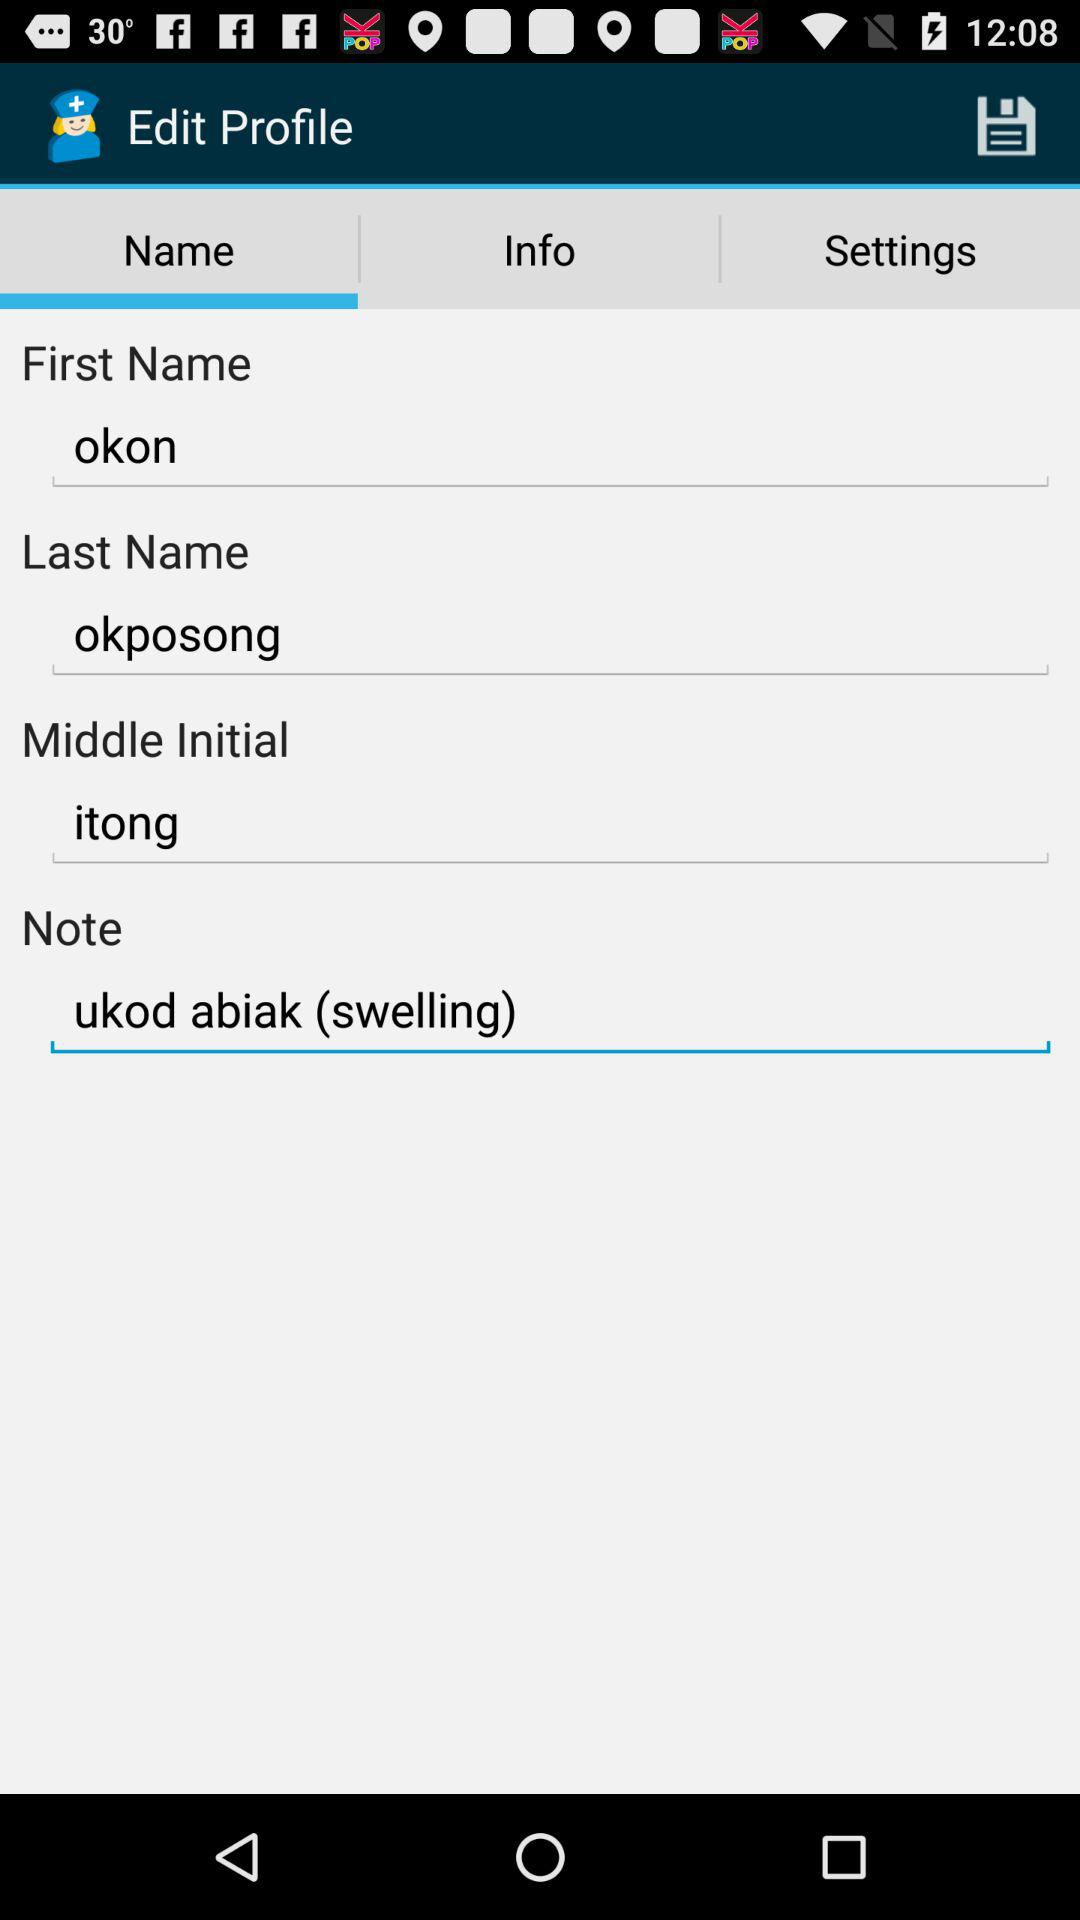What is the user's first name? The user's first name is okon. 